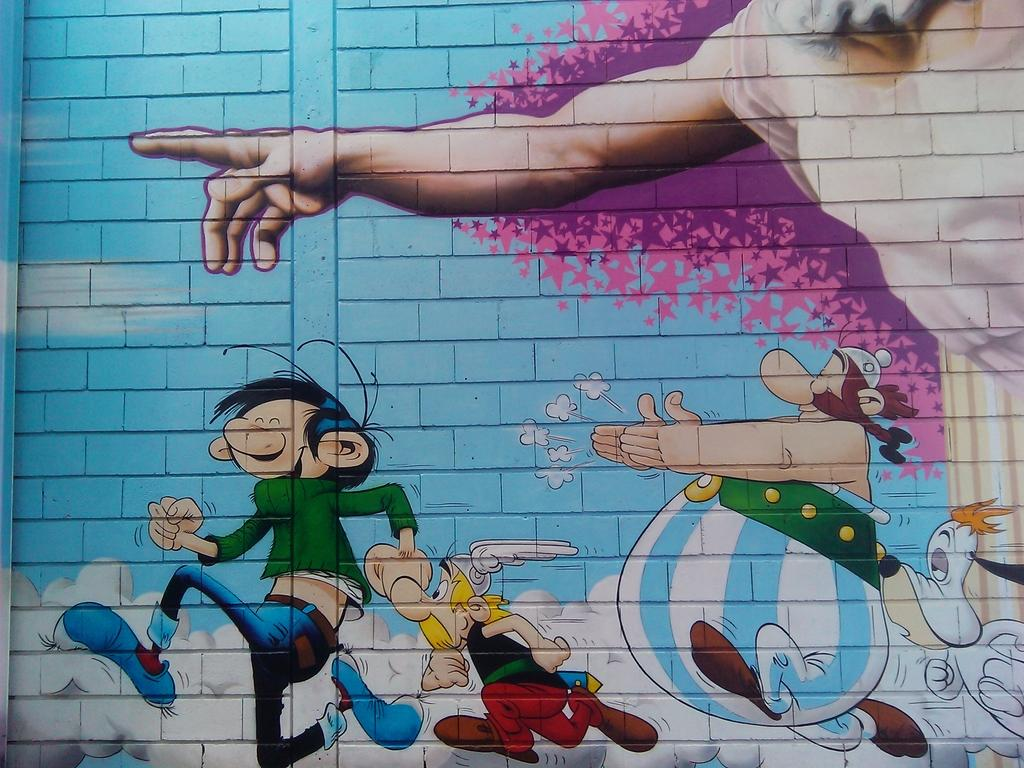What is present on the wall in the image? There is a painting of persons on the wall. What else can be seen in the image besides the wall and painting? There are toys in the image. Where is the faucet located in the image? There is no faucet present in the image. Does the existence of the painting on the wall imply the end of the wall? The presence of the painting on the wall does not imply the end of the wall; it is simply an artwork placed on the wall. 